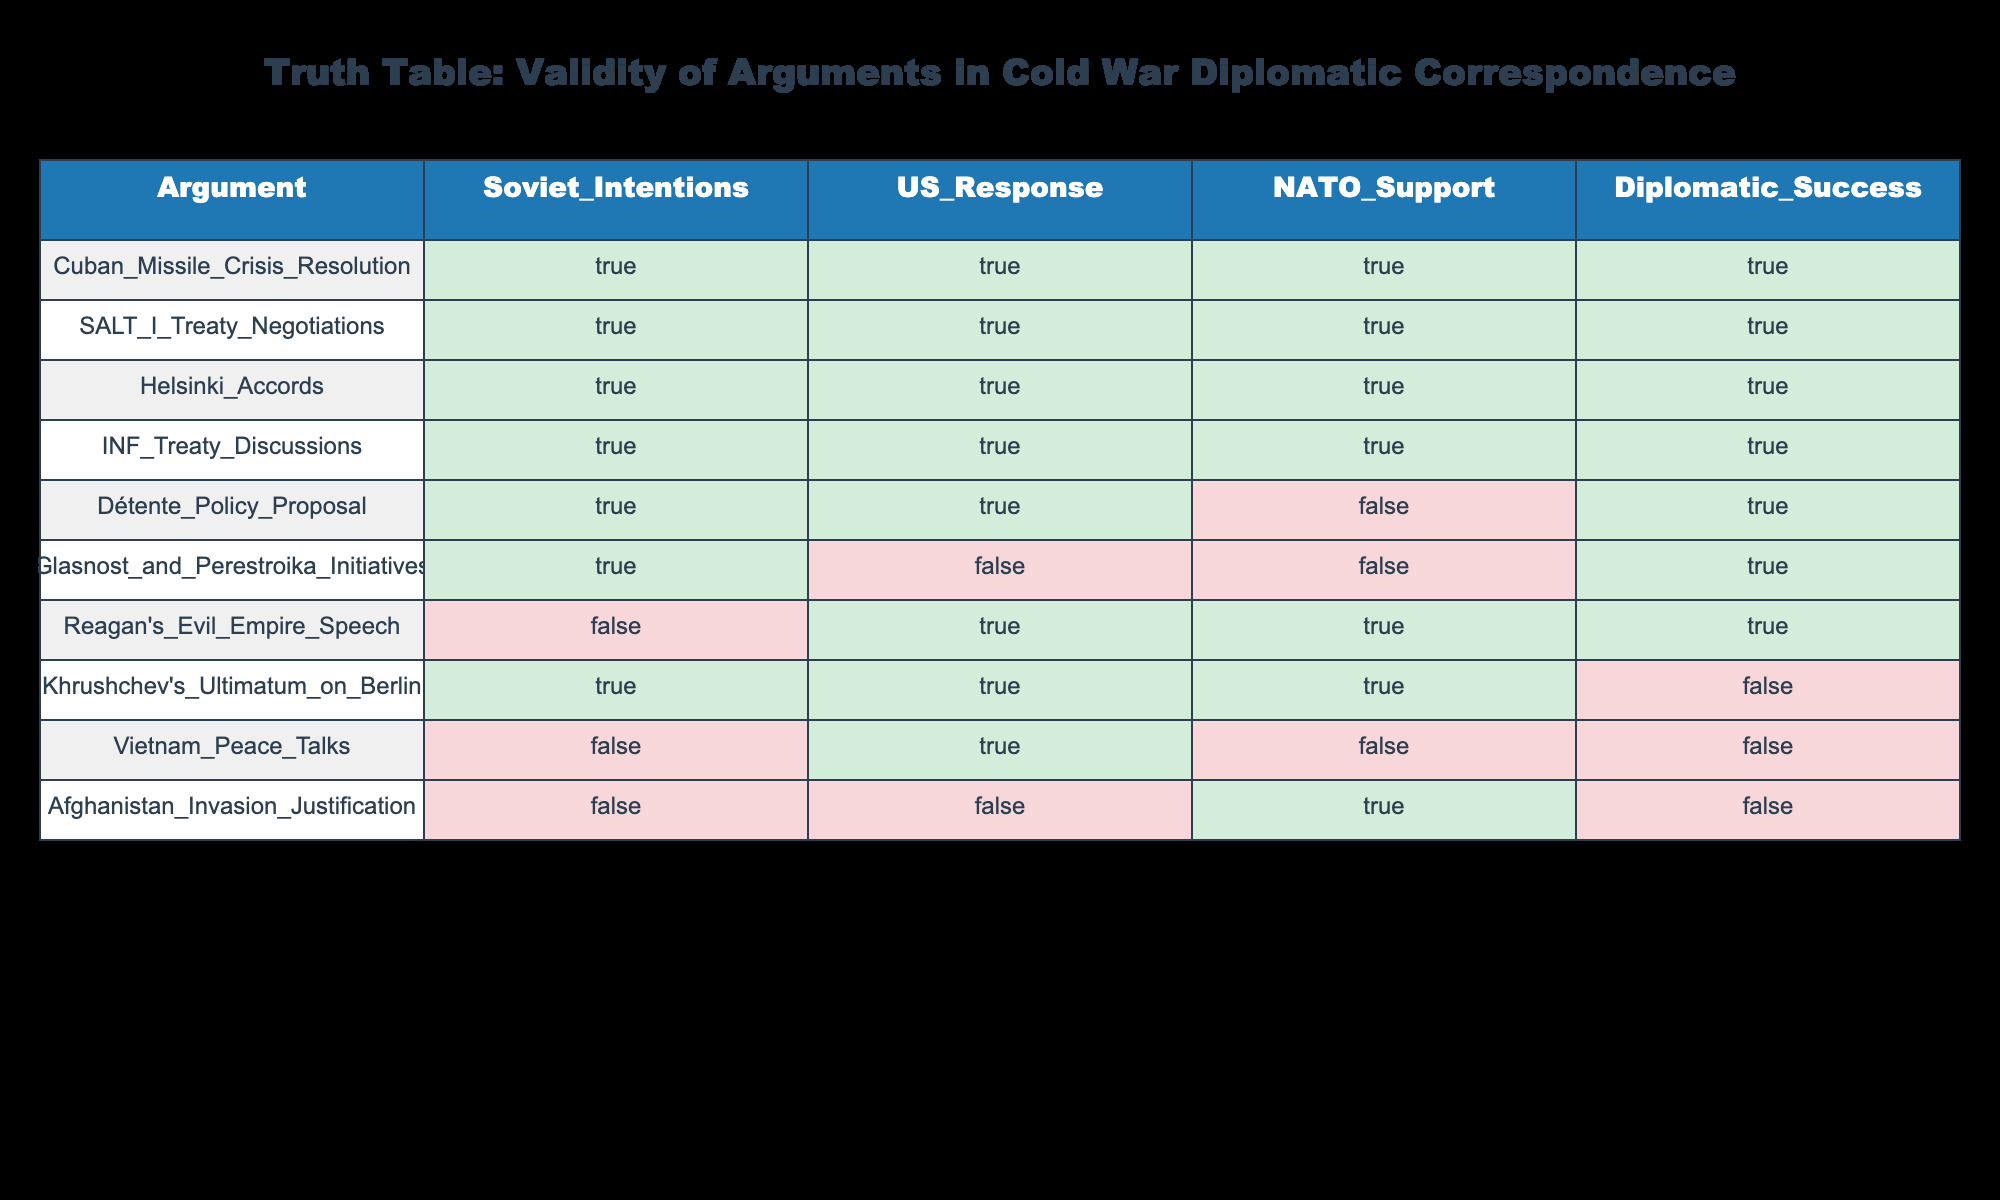What is the diplomatic success rate for arguments that received NATO support? To determine this, we look for arguments where NATO support is marked as true. In the table, the arguments with NATO support are: Khrushchev's Ultimatum on Berlin, Cuban Missile Crisis Resolution, SALT I Treaty Negotiations, Helsinki Accords, INF Treaty Discussions, and Reagan's Evil Empire Speech. Out of these, the ones with diplomatic success are: Cuban Missile Crisis Resolution, SALT I Treaty Negotiations, Helsinki Accords, and INF Treaty Discussions. This gives us 4 successful arguments out of 6 with NATO support, resulting in a success rate of 4 out of 6, or approximately 66.67%.
Answer: 66.67% How many arguments feature both true Soviet intentions and true US responses? We count the number of rows where both Soviet intentions and US responses are marked as true. From the table, the relevant arguments are: Khrushchev's Ultimatum on Berlin, Cuban Missile Crisis Resolution, Détente Policy Proposal, SALT I Treaty Negotiations, Helsinki Accords, and INF Treaty Discussions. Counting these gives us a total of 6 arguments that meet this criterion.
Answer: 6 Is the argument for Afghanistan's invasion justified according to the table? The table indicates that both Soviet intentions and US responses are false for the argument of Afghanistan invasion justification. Since both are false, it suggests that this argument lacks validity regarding justification in diplomatic terms.
Answer: No Which argument has true Soviet intentions but resulted in diplomatic failure? We need to find an argument that has true Soviet intentions (marked as true) but also has diplomatic success marked as false. Looking at the table, the arguments that match this criterion are: Khrushchev's Ultimatum on Berlin and Afghanistan Invasion Justification. Both have true Soviet intentions and are marked as achieving diplomatic failure.
Answer: Khrushchev's Ultimatum on Berlin, Afghanistan Invasion Justification What is the total number of arguments that led to diplomatic success? We will count the arguments in the table marked as diplomatic success (true). These arguments are: Cuban Missile Crisis Resolution, Détente Policy Proposal, SALT I Treaty Negotiations, Helsinki Accords, Reagan's Evil Empire Speech, INF Treaty Discussions, and Glasnost and Perestroika Initiatives. In total, there are 5 arguments that led to diplomatic success.
Answer: 5 Are there any arguments that managed to succeed diplomatically despite a lack of NATO support? We need to identify arguments where diplomatic success is true while NATO support is false. The arguments that fit this condition are Détente Policy Proposal, Glasnost and Perestroika Initiatives. Therefore, there are 2 arguments that have succeeded diplomatically without NATO support.
Answer: Yes, 2 arguments 